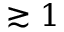Convert formula to latex. <formula><loc_0><loc_0><loc_500><loc_500>\gtrsim 1</formula> 